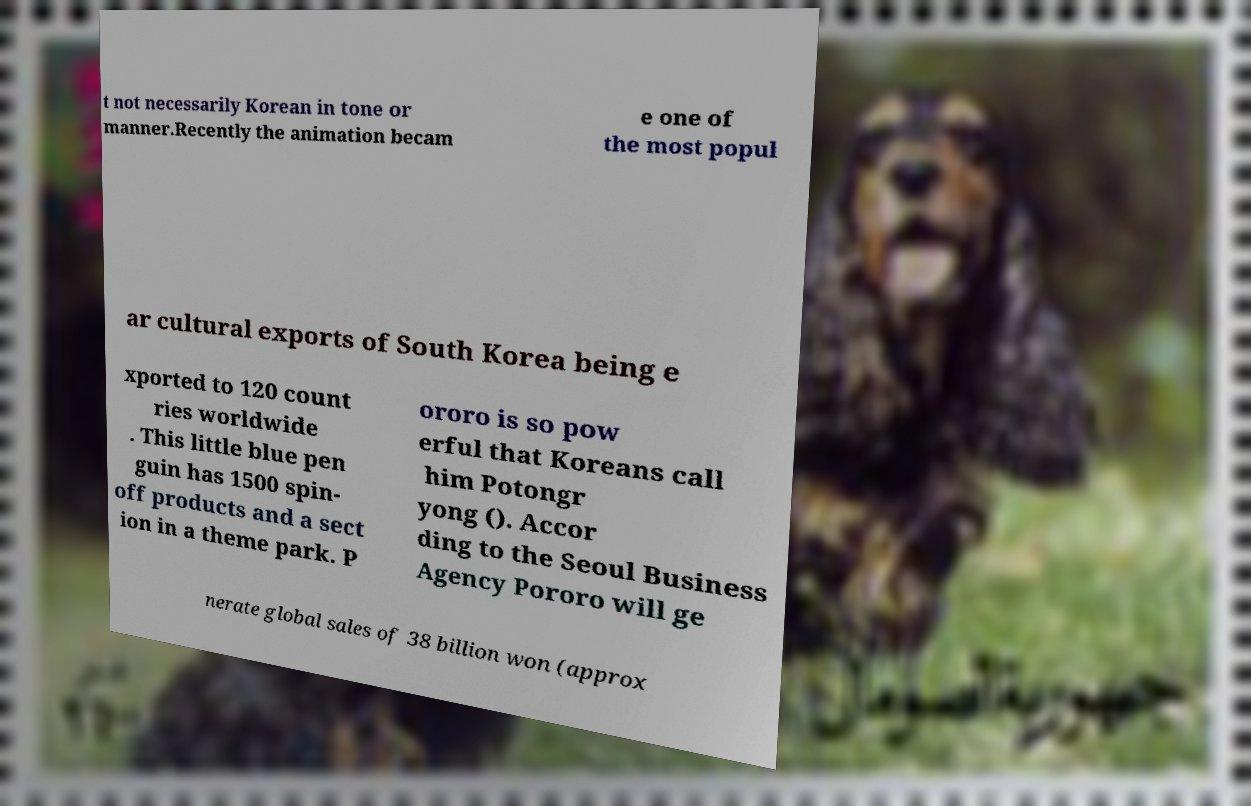There's text embedded in this image that I need extracted. Can you transcribe it verbatim? t not necessarily Korean in tone or manner.Recently the animation becam e one of the most popul ar cultural exports of South Korea being e xported to 120 count ries worldwide . This little blue pen guin has 1500 spin- off products and a sect ion in a theme park. P ororo is so pow erful that Koreans call him Potongr yong (). Accor ding to the Seoul Business Agency Pororo will ge nerate global sales of 38 billion won (approx 